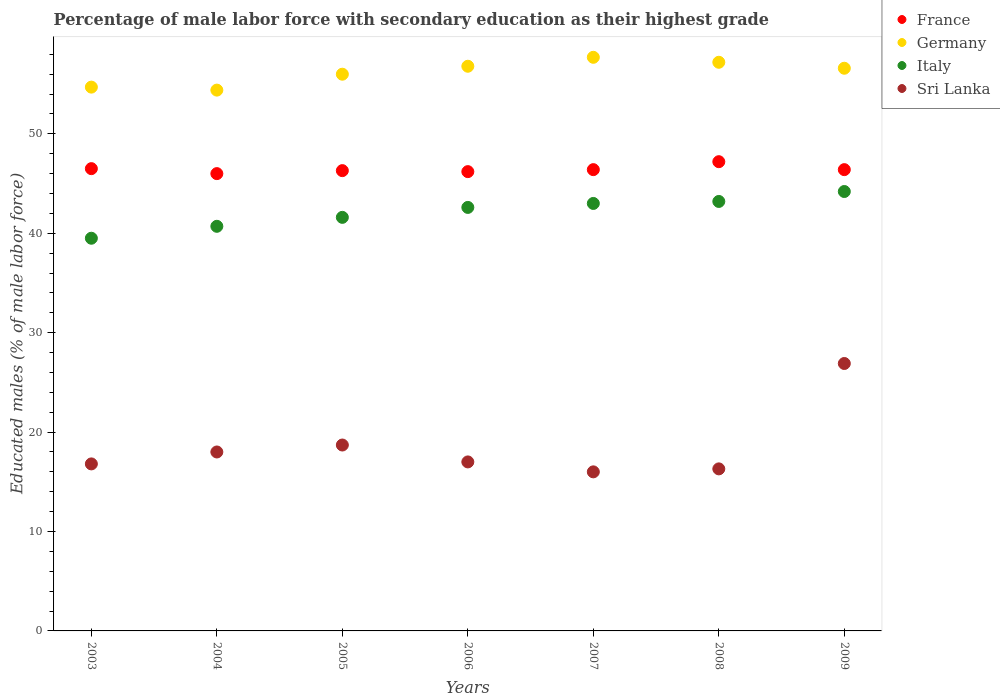How many different coloured dotlines are there?
Your answer should be very brief. 4. Across all years, what is the maximum percentage of male labor force with secondary education in Italy?
Provide a succinct answer. 44.2. Across all years, what is the minimum percentage of male labor force with secondary education in Italy?
Make the answer very short. 39.5. In which year was the percentage of male labor force with secondary education in France maximum?
Offer a very short reply. 2008. What is the total percentage of male labor force with secondary education in Sri Lanka in the graph?
Give a very brief answer. 129.7. What is the difference between the percentage of male labor force with secondary education in Germany in 2004 and that in 2005?
Give a very brief answer. -1.6. What is the difference between the percentage of male labor force with secondary education in Italy in 2005 and the percentage of male labor force with secondary education in Sri Lanka in 2009?
Make the answer very short. 14.7. What is the average percentage of male labor force with secondary education in Italy per year?
Provide a succinct answer. 42.11. In the year 2006, what is the difference between the percentage of male labor force with secondary education in France and percentage of male labor force with secondary education in Italy?
Give a very brief answer. 3.6. What is the ratio of the percentage of male labor force with secondary education in Sri Lanka in 2005 to that in 2008?
Provide a succinct answer. 1.15. What is the difference between the highest and the second highest percentage of male labor force with secondary education in Sri Lanka?
Provide a short and direct response. 8.2. What is the difference between the highest and the lowest percentage of male labor force with secondary education in Italy?
Offer a very short reply. 4.7. In how many years, is the percentage of male labor force with secondary education in Italy greater than the average percentage of male labor force with secondary education in Italy taken over all years?
Offer a terse response. 4. Is it the case that in every year, the sum of the percentage of male labor force with secondary education in Italy and percentage of male labor force with secondary education in Sri Lanka  is greater than the sum of percentage of male labor force with secondary education in France and percentage of male labor force with secondary education in Germany?
Provide a succinct answer. No. Does the percentage of male labor force with secondary education in Sri Lanka monotonically increase over the years?
Offer a very short reply. No. Is the percentage of male labor force with secondary education in Italy strictly greater than the percentage of male labor force with secondary education in France over the years?
Offer a very short reply. No. What is the difference between two consecutive major ticks on the Y-axis?
Provide a succinct answer. 10. Are the values on the major ticks of Y-axis written in scientific E-notation?
Offer a terse response. No. Where does the legend appear in the graph?
Your response must be concise. Top right. How many legend labels are there?
Offer a terse response. 4. What is the title of the graph?
Provide a short and direct response. Percentage of male labor force with secondary education as their highest grade. Does "Moldova" appear as one of the legend labels in the graph?
Your response must be concise. No. What is the label or title of the X-axis?
Keep it short and to the point. Years. What is the label or title of the Y-axis?
Make the answer very short. Educated males (% of male labor force). What is the Educated males (% of male labor force) in France in 2003?
Offer a very short reply. 46.5. What is the Educated males (% of male labor force) of Germany in 2003?
Provide a short and direct response. 54.7. What is the Educated males (% of male labor force) of Italy in 2003?
Offer a terse response. 39.5. What is the Educated males (% of male labor force) in Sri Lanka in 2003?
Your answer should be very brief. 16.8. What is the Educated males (% of male labor force) in France in 2004?
Offer a very short reply. 46. What is the Educated males (% of male labor force) in Germany in 2004?
Your answer should be compact. 54.4. What is the Educated males (% of male labor force) of Italy in 2004?
Make the answer very short. 40.7. What is the Educated males (% of male labor force) in France in 2005?
Your answer should be compact. 46.3. What is the Educated males (% of male labor force) in Italy in 2005?
Make the answer very short. 41.6. What is the Educated males (% of male labor force) of Sri Lanka in 2005?
Give a very brief answer. 18.7. What is the Educated males (% of male labor force) of France in 2006?
Keep it short and to the point. 46.2. What is the Educated males (% of male labor force) in Germany in 2006?
Your answer should be compact. 56.8. What is the Educated males (% of male labor force) of Italy in 2006?
Provide a short and direct response. 42.6. What is the Educated males (% of male labor force) in France in 2007?
Offer a very short reply. 46.4. What is the Educated males (% of male labor force) in Germany in 2007?
Offer a very short reply. 57.7. What is the Educated males (% of male labor force) in Italy in 2007?
Give a very brief answer. 43. What is the Educated males (% of male labor force) in France in 2008?
Your answer should be compact. 47.2. What is the Educated males (% of male labor force) of Germany in 2008?
Provide a short and direct response. 57.2. What is the Educated males (% of male labor force) in Italy in 2008?
Ensure brevity in your answer.  43.2. What is the Educated males (% of male labor force) in Sri Lanka in 2008?
Give a very brief answer. 16.3. What is the Educated males (% of male labor force) in France in 2009?
Make the answer very short. 46.4. What is the Educated males (% of male labor force) of Germany in 2009?
Keep it short and to the point. 56.6. What is the Educated males (% of male labor force) in Italy in 2009?
Offer a very short reply. 44.2. What is the Educated males (% of male labor force) of Sri Lanka in 2009?
Make the answer very short. 26.9. Across all years, what is the maximum Educated males (% of male labor force) in France?
Your answer should be compact. 47.2. Across all years, what is the maximum Educated males (% of male labor force) of Germany?
Your response must be concise. 57.7. Across all years, what is the maximum Educated males (% of male labor force) in Italy?
Keep it short and to the point. 44.2. Across all years, what is the maximum Educated males (% of male labor force) of Sri Lanka?
Offer a very short reply. 26.9. Across all years, what is the minimum Educated males (% of male labor force) in France?
Give a very brief answer. 46. Across all years, what is the minimum Educated males (% of male labor force) of Germany?
Your answer should be very brief. 54.4. Across all years, what is the minimum Educated males (% of male labor force) in Italy?
Offer a terse response. 39.5. What is the total Educated males (% of male labor force) in France in the graph?
Make the answer very short. 325. What is the total Educated males (% of male labor force) of Germany in the graph?
Provide a succinct answer. 393.4. What is the total Educated males (% of male labor force) in Italy in the graph?
Provide a succinct answer. 294.8. What is the total Educated males (% of male labor force) in Sri Lanka in the graph?
Keep it short and to the point. 129.7. What is the difference between the Educated males (% of male labor force) in France in 2003 and that in 2004?
Your response must be concise. 0.5. What is the difference between the Educated males (% of male labor force) in Germany in 2003 and that in 2004?
Your response must be concise. 0.3. What is the difference between the Educated males (% of male labor force) in Sri Lanka in 2003 and that in 2004?
Keep it short and to the point. -1.2. What is the difference between the Educated males (% of male labor force) in Germany in 2003 and that in 2005?
Give a very brief answer. -1.3. What is the difference between the Educated males (% of male labor force) of Italy in 2003 and that in 2005?
Your answer should be very brief. -2.1. What is the difference between the Educated males (% of male labor force) in Sri Lanka in 2003 and that in 2005?
Provide a short and direct response. -1.9. What is the difference between the Educated males (% of male labor force) in France in 2003 and that in 2006?
Give a very brief answer. 0.3. What is the difference between the Educated males (% of male labor force) of Germany in 2003 and that in 2006?
Your response must be concise. -2.1. What is the difference between the Educated males (% of male labor force) of Italy in 2003 and that in 2006?
Ensure brevity in your answer.  -3.1. What is the difference between the Educated males (% of male labor force) of France in 2003 and that in 2007?
Your answer should be compact. 0.1. What is the difference between the Educated males (% of male labor force) of Sri Lanka in 2003 and that in 2007?
Your response must be concise. 0.8. What is the difference between the Educated males (% of male labor force) in France in 2003 and that in 2008?
Keep it short and to the point. -0.7. What is the difference between the Educated males (% of male labor force) of Germany in 2003 and that in 2008?
Give a very brief answer. -2.5. What is the difference between the Educated males (% of male labor force) of Italy in 2003 and that in 2008?
Provide a succinct answer. -3.7. What is the difference between the Educated males (% of male labor force) in France in 2003 and that in 2009?
Offer a terse response. 0.1. What is the difference between the Educated males (% of male labor force) of Italy in 2003 and that in 2009?
Make the answer very short. -4.7. What is the difference between the Educated males (% of male labor force) of Sri Lanka in 2003 and that in 2009?
Provide a succinct answer. -10.1. What is the difference between the Educated males (% of male labor force) of France in 2004 and that in 2005?
Offer a very short reply. -0.3. What is the difference between the Educated males (% of male labor force) of Germany in 2004 and that in 2005?
Offer a very short reply. -1.6. What is the difference between the Educated males (% of male labor force) of Italy in 2004 and that in 2005?
Your answer should be compact. -0.9. What is the difference between the Educated males (% of male labor force) of Sri Lanka in 2004 and that in 2005?
Keep it short and to the point. -0.7. What is the difference between the Educated males (% of male labor force) in France in 2004 and that in 2006?
Offer a terse response. -0.2. What is the difference between the Educated males (% of male labor force) in Germany in 2004 and that in 2006?
Your answer should be compact. -2.4. What is the difference between the Educated males (% of male labor force) of Sri Lanka in 2004 and that in 2006?
Ensure brevity in your answer.  1. What is the difference between the Educated males (% of male labor force) of France in 2004 and that in 2007?
Give a very brief answer. -0.4. What is the difference between the Educated males (% of male labor force) in France in 2004 and that in 2008?
Keep it short and to the point. -1.2. What is the difference between the Educated males (% of male labor force) in Germany in 2004 and that in 2008?
Offer a terse response. -2.8. What is the difference between the Educated males (% of male labor force) in Italy in 2004 and that in 2008?
Make the answer very short. -2.5. What is the difference between the Educated males (% of male labor force) in France in 2005 and that in 2006?
Give a very brief answer. 0.1. What is the difference between the Educated males (% of male labor force) in Germany in 2005 and that in 2006?
Provide a succinct answer. -0.8. What is the difference between the Educated males (% of male labor force) in Italy in 2005 and that in 2006?
Provide a short and direct response. -1. What is the difference between the Educated males (% of male labor force) of France in 2005 and that in 2007?
Your response must be concise. -0.1. What is the difference between the Educated males (% of male labor force) of France in 2005 and that in 2008?
Offer a very short reply. -0.9. What is the difference between the Educated males (% of male labor force) in Italy in 2005 and that in 2008?
Your response must be concise. -1.6. What is the difference between the Educated males (% of male labor force) of Sri Lanka in 2005 and that in 2008?
Offer a very short reply. 2.4. What is the difference between the Educated males (% of male labor force) of France in 2005 and that in 2009?
Keep it short and to the point. -0.1. What is the difference between the Educated males (% of male labor force) in Germany in 2005 and that in 2009?
Keep it short and to the point. -0.6. What is the difference between the Educated males (% of male labor force) of Italy in 2005 and that in 2009?
Give a very brief answer. -2.6. What is the difference between the Educated males (% of male labor force) in France in 2006 and that in 2007?
Make the answer very short. -0.2. What is the difference between the Educated males (% of male labor force) in Germany in 2006 and that in 2007?
Make the answer very short. -0.9. What is the difference between the Educated males (% of male labor force) in Sri Lanka in 2006 and that in 2007?
Ensure brevity in your answer.  1. What is the difference between the Educated males (% of male labor force) in Germany in 2006 and that in 2008?
Give a very brief answer. -0.4. What is the difference between the Educated males (% of male labor force) in Italy in 2006 and that in 2008?
Offer a terse response. -0.6. What is the difference between the Educated males (% of male labor force) in France in 2006 and that in 2009?
Your answer should be very brief. -0.2. What is the difference between the Educated males (% of male labor force) of Sri Lanka in 2006 and that in 2009?
Ensure brevity in your answer.  -9.9. What is the difference between the Educated males (% of male labor force) of Italy in 2007 and that in 2008?
Ensure brevity in your answer.  -0.2. What is the difference between the Educated males (% of male labor force) in France in 2007 and that in 2009?
Your response must be concise. 0. What is the difference between the Educated males (% of male labor force) in Germany in 2007 and that in 2009?
Give a very brief answer. 1.1. What is the difference between the Educated males (% of male labor force) in Sri Lanka in 2007 and that in 2009?
Offer a terse response. -10.9. What is the difference between the Educated males (% of male labor force) in France in 2008 and that in 2009?
Offer a terse response. 0.8. What is the difference between the Educated males (% of male labor force) in Germany in 2008 and that in 2009?
Give a very brief answer. 0.6. What is the difference between the Educated males (% of male labor force) in Sri Lanka in 2008 and that in 2009?
Your response must be concise. -10.6. What is the difference between the Educated males (% of male labor force) in France in 2003 and the Educated males (% of male labor force) in Germany in 2004?
Your answer should be compact. -7.9. What is the difference between the Educated males (% of male labor force) of Germany in 2003 and the Educated males (% of male labor force) of Italy in 2004?
Your answer should be compact. 14. What is the difference between the Educated males (% of male labor force) in Germany in 2003 and the Educated males (% of male labor force) in Sri Lanka in 2004?
Offer a terse response. 36.7. What is the difference between the Educated males (% of male labor force) of Italy in 2003 and the Educated males (% of male labor force) of Sri Lanka in 2004?
Your answer should be very brief. 21.5. What is the difference between the Educated males (% of male labor force) of France in 2003 and the Educated males (% of male labor force) of Germany in 2005?
Provide a short and direct response. -9.5. What is the difference between the Educated males (% of male labor force) in France in 2003 and the Educated males (% of male labor force) in Italy in 2005?
Your response must be concise. 4.9. What is the difference between the Educated males (% of male labor force) of France in 2003 and the Educated males (% of male labor force) of Sri Lanka in 2005?
Ensure brevity in your answer.  27.8. What is the difference between the Educated males (% of male labor force) in Germany in 2003 and the Educated males (% of male labor force) in Italy in 2005?
Give a very brief answer. 13.1. What is the difference between the Educated males (% of male labor force) in Germany in 2003 and the Educated males (% of male labor force) in Sri Lanka in 2005?
Give a very brief answer. 36. What is the difference between the Educated males (% of male labor force) in Italy in 2003 and the Educated males (% of male labor force) in Sri Lanka in 2005?
Give a very brief answer. 20.8. What is the difference between the Educated males (% of male labor force) in France in 2003 and the Educated males (% of male labor force) in Italy in 2006?
Offer a very short reply. 3.9. What is the difference between the Educated males (% of male labor force) in France in 2003 and the Educated males (% of male labor force) in Sri Lanka in 2006?
Make the answer very short. 29.5. What is the difference between the Educated males (% of male labor force) in Germany in 2003 and the Educated males (% of male labor force) in Italy in 2006?
Make the answer very short. 12.1. What is the difference between the Educated males (% of male labor force) of Germany in 2003 and the Educated males (% of male labor force) of Sri Lanka in 2006?
Provide a short and direct response. 37.7. What is the difference between the Educated males (% of male labor force) of Italy in 2003 and the Educated males (% of male labor force) of Sri Lanka in 2006?
Make the answer very short. 22.5. What is the difference between the Educated males (% of male labor force) in France in 2003 and the Educated males (% of male labor force) in Italy in 2007?
Provide a short and direct response. 3.5. What is the difference between the Educated males (% of male labor force) in France in 2003 and the Educated males (% of male labor force) in Sri Lanka in 2007?
Your answer should be compact. 30.5. What is the difference between the Educated males (% of male labor force) in Germany in 2003 and the Educated males (% of male labor force) in Italy in 2007?
Make the answer very short. 11.7. What is the difference between the Educated males (% of male labor force) of Germany in 2003 and the Educated males (% of male labor force) of Sri Lanka in 2007?
Offer a very short reply. 38.7. What is the difference between the Educated males (% of male labor force) in France in 2003 and the Educated males (% of male labor force) in Germany in 2008?
Offer a very short reply. -10.7. What is the difference between the Educated males (% of male labor force) in France in 2003 and the Educated males (% of male labor force) in Sri Lanka in 2008?
Offer a very short reply. 30.2. What is the difference between the Educated males (% of male labor force) of Germany in 2003 and the Educated males (% of male labor force) of Italy in 2008?
Ensure brevity in your answer.  11.5. What is the difference between the Educated males (% of male labor force) of Germany in 2003 and the Educated males (% of male labor force) of Sri Lanka in 2008?
Provide a short and direct response. 38.4. What is the difference between the Educated males (% of male labor force) in Italy in 2003 and the Educated males (% of male labor force) in Sri Lanka in 2008?
Your answer should be compact. 23.2. What is the difference between the Educated males (% of male labor force) of France in 2003 and the Educated males (% of male labor force) of Germany in 2009?
Ensure brevity in your answer.  -10.1. What is the difference between the Educated males (% of male labor force) of France in 2003 and the Educated males (% of male labor force) of Italy in 2009?
Provide a short and direct response. 2.3. What is the difference between the Educated males (% of male labor force) of France in 2003 and the Educated males (% of male labor force) of Sri Lanka in 2009?
Offer a terse response. 19.6. What is the difference between the Educated males (% of male labor force) of Germany in 2003 and the Educated males (% of male labor force) of Italy in 2009?
Offer a terse response. 10.5. What is the difference between the Educated males (% of male labor force) of Germany in 2003 and the Educated males (% of male labor force) of Sri Lanka in 2009?
Your answer should be very brief. 27.8. What is the difference between the Educated males (% of male labor force) of Italy in 2003 and the Educated males (% of male labor force) of Sri Lanka in 2009?
Provide a succinct answer. 12.6. What is the difference between the Educated males (% of male labor force) in France in 2004 and the Educated males (% of male labor force) in Italy in 2005?
Your answer should be very brief. 4.4. What is the difference between the Educated males (% of male labor force) in France in 2004 and the Educated males (% of male labor force) in Sri Lanka in 2005?
Your answer should be compact. 27.3. What is the difference between the Educated males (% of male labor force) of Germany in 2004 and the Educated males (% of male labor force) of Sri Lanka in 2005?
Your answer should be very brief. 35.7. What is the difference between the Educated males (% of male labor force) of France in 2004 and the Educated males (% of male labor force) of Germany in 2006?
Provide a short and direct response. -10.8. What is the difference between the Educated males (% of male labor force) in Germany in 2004 and the Educated males (% of male labor force) in Sri Lanka in 2006?
Make the answer very short. 37.4. What is the difference between the Educated males (% of male labor force) of Italy in 2004 and the Educated males (% of male labor force) of Sri Lanka in 2006?
Offer a very short reply. 23.7. What is the difference between the Educated males (% of male labor force) of France in 2004 and the Educated males (% of male labor force) of Italy in 2007?
Ensure brevity in your answer.  3. What is the difference between the Educated males (% of male labor force) of France in 2004 and the Educated males (% of male labor force) of Sri Lanka in 2007?
Give a very brief answer. 30. What is the difference between the Educated males (% of male labor force) of Germany in 2004 and the Educated males (% of male labor force) of Italy in 2007?
Offer a terse response. 11.4. What is the difference between the Educated males (% of male labor force) in Germany in 2004 and the Educated males (% of male labor force) in Sri Lanka in 2007?
Ensure brevity in your answer.  38.4. What is the difference between the Educated males (% of male labor force) of Italy in 2004 and the Educated males (% of male labor force) of Sri Lanka in 2007?
Keep it short and to the point. 24.7. What is the difference between the Educated males (% of male labor force) of France in 2004 and the Educated males (% of male labor force) of Germany in 2008?
Make the answer very short. -11.2. What is the difference between the Educated males (% of male labor force) in France in 2004 and the Educated males (% of male labor force) in Italy in 2008?
Offer a very short reply. 2.8. What is the difference between the Educated males (% of male labor force) of France in 2004 and the Educated males (% of male labor force) of Sri Lanka in 2008?
Keep it short and to the point. 29.7. What is the difference between the Educated males (% of male labor force) of Germany in 2004 and the Educated males (% of male labor force) of Italy in 2008?
Make the answer very short. 11.2. What is the difference between the Educated males (% of male labor force) in Germany in 2004 and the Educated males (% of male labor force) in Sri Lanka in 2008?
Ensure brevity in your answer.  38.1. What is the difference between the Educated males (% of male labor force) in Italy in 2004 and the Educated males (% of male labor force) in Sri Lanka in 2008?
Ensure brevity in your answer.  24.4. What is the difference between the Educated males (% of male labor force) in France in 2004 and the Educated males (% of male labor force) in Italy in 2009?
Ensure brevity in your answer.  1.8. What is the difference between the Educated males (% of male labor force) in France in 2004 and the Educated males (% of male labor force) in Sri Lanka in 2009?
Provide a short and direct response. 19.1. What is the difference between the Educated males (% of male labor force) of Germany in 2004 and the Educated males (% of male labor force) of Italy in 2009?
Provide a succinct answer. 10.2. What is the difference between the Educated males (% of male labor force) of Germany in 2004 and the Educated males (% of male labor force) of Sri Lanka in 2009?
Give a very brief answer. 27.5. What is the difference between the Educated males (% of male labor force) in France in 2005 and the Educated males (% of male labor force) in Italy in 2006?
Offer a very short reply. 3.7. What is the difference between the Educated males (% of male labor force) in France in 2005 and the Educated males (% of male labor force) in Sri Lanka in 2006?
Make the answer very short. 29.3. What is the difference between the Educated males (% of male labor force) in Italy in 2005 and the Educated males (% of male labor force) in Sri Lanka in 2006?
Offer a terse response. 24.6. What is the difference between the Educated males (% of male labor force) of France in 2005 and the Educated males (% of male labor force) of Germany in 2007?
Provide a succinct answer. -11.4. What is the difference between the Educated males (% of male labor force) of France in 2005 and the Educated males (% of male labor force) of Italy in 2007?
Keep it short and to the point. 3.3. What is the difference between the Educated males (% of male labor force) in France in 2005 and the Educated males (% of male labor force) in Sri Lanka in 2007?
Offer a very short reply. 30.3. What is the difference between the Educated males (% of male labor force) in Germany in 2005 and the Educated males (% of male labor force) in Italy in 2007?
Your answer should be compact. 13. What is the difference between the Educated males (% of male labor force) of Germany in 2005 and the Educated males (% of male labor force) of Sri Lanka in 2007?
Provide a short and direct response. 40. What is the difference between the Educated males (% of male labor force) in Italy in 2005 and the Educated males (% of male labor force) in Sri Lanka in 2007?
Your answer should be very brief. 25.6. What is the difference between the Educated males (% of male labor force) of France in 2005 and the Educated males (% of male labor force) of Germany in 2008?
Your response must be concise. -10.9. What is the difference between the Educated males (% of male labor force) in France in 2005 and the Educated males (% of male labor force) in Sri Lanka in 2008?
Make the answer very short. 30. What is the difference between the Educated males (% of male labor force) of Germany in 2005 and the Educated males (% of male labor force) of Italy in 2008?
Your answer should be very brief. 12.8. What is the difference between the Educated males (% of male labor force) in Germany in 2005 and the Educated males (% of male labor force) in Sri Lanka in 2008?
Offer a very short reply. 39.7. What is the difference between the Educated males (% of male labor force) of Italy in 2005 and the Educated males (% of male labor force) of Sri Lanka in 2008?
Offer a very short reply. 25.3. What is the difference between the Educated males (% of male labor force) in France in 2005 and the Educated males (% of male labor force) in Germany in 2009?
Keep it short and to the point. -10.3. What is the difference between the Educated males (% of male labor force) in France in 2005 and the Educated males (% of male labor force) in Italy in 2009?
Give a very brief answer. 2.1. What is the difference between the Educated males (% of male labor force) in Germany in 2005 and the Educated males (% of male labor force) in Sri Lanka in 2009?
Your response must be concise. 29.1. What is the difference between the Educated males (% of male labor force) in Italy in 2005 and the Educated males (% of male labor force) in Sri Lanka in 2009?
Offer a terse response. 14.7. What is the difference between the Educated males (% of male labor force) of France in 2006 and the Educated males (% of male labor force) of Germany in 2007?
Give a very brief answer. -11.5. What is the difference between the Educated males (% of male labor force) of France in 2006 and the Educated males (% of male labor force) of Sri Lanka in 2007?
Provide a succinct answer. 30.2. What is the difference between the Educated males (% of male labor force) in Germany in 2006 and the Educated males (% of male labor force) in Sri Lanka in 2007?
Give a very brief answer. 40.8. What is the difference between the Educated males (% of male labor force) in Italy in 2006 and the Educated males (% of male labor force) in Sri Lanka in 2007?
Make the answer very short. 26.6. What is the difference between the Educated males (% of male labor force) of France in 2006 and the Educated males (% of male labor force) of Germany in 2008?
Offer a terse response. -11. What is the difference between the Educated males (% of male labor force) in France in 2006 and the Educated males (% of male labor force) in Italy in 2008?
Give a very brief answer. 3. What is the difference between the Educated males (% of male labor force) in France in 2006 and the Educated males (% of male labor force) in Sri Lanka in 2008?
Your response must be concise. 29.9. What is the difference between the Educated males (% of male labor force) in Germany in 2006 and the Educated males (% of male labor force) in Sri Lanka in 2008?
Your answer should be very brief. 40.5. What is the difference between the Educated males (% of male labor force) in Italy in 2006 and the Educated males (% of male labor force) in Sri Lanka in 2008?
Provide a succinct answer. 26.3. What is the difference between the Educated males (% of male labor force) of France in 2006 and the Educated males (% of male labor force) of Italy in 2009?
Keep it short and to the point. 2. What is the difference between the Educated males (% of male labor force) of France in 2006 and the Educated males (% of male labor force) of Sri Lanka in 2009?
Make the answer very short. 19.3. What is the difference between the Educated males (% of male labor force) in Germany in 2006 and the Educated males (% of male labor force) in Sri Lanka in 2009?
Provide a short and direct response. 29.9. What is the difference between the Educated males (% of male labor force) in France in 2007 and the Educated males (% of male labor force) in Germany in 2008?
Provide a succinct answer. -10.8. What is the difference between the Educated males (% of male labor force) of France in 2007 and the Educated males (% of male labor force) of Sri Lanka in 2008?
Your answer should be very brief. 30.1. What is the difference between the Educated males (% of male labor force) of Germany in 2007 and the Educated males (% of male labor force) of Italy in 2008?
Give a very brief answer. 14.5. What is the difference between the Educated males (% of male labor force) in Germany in 2007 and the Educated males (% of male labor force) in Sri Lanka in 2008?
Offer a very short reply. 41.4. What is the difference between the Educated males (% of male labor force) in Italy in 2007 and the Educated males (% of male labor force) in Sri Lanka in 2008?
Give a very brief answer. 26.7. What is the difference between the Educated males (% of male labor force) in France in 2007 and the Educated males (% of male labor force) in Germany in 2009?
Keep it short and to the point. -10.2. What is the difference between the Educated males (% of male labor force) in France in 2007 and the Educated males (% of male labor force) in Sri Lanka in 2009?
Offer a terse response. 19.5. What is the difference between the Educated males (% of male labor force) in Germany in 2007 and the Educated males (% of male labor force) in Italy in 2009?
Provide a short and direct response. 13.5. What is the difference between the Educated males (% of male labor force) of Germany in 2007 and the Educated males (% of male labor force) of Sri Lanka in 2009?
Ensure brevity in your answer.  30.8. What is the difference between the Educated males (% of male labor force) of Italy in 2007 and the Educated males (% of male labor force) of Sri Lanka in 2009?
Provide a succinct answer. 16.1. What is the difference between the Educated males (% of male labor force) of France in 2008 and the Educated males (% of male labor force) of Sri Lanka in 2009?
Make the answer very short. 20.3. What is the difference between the Educated males (% of male labor force) of Germany in 2008 and the Educated males (% of male labor force) of Sri Lanka in 2009?
Offer a very short reply. 30.3. What is the difference between the Educated males (% of male labor force) in Italy in 2008 and the Educated males (% of male labor force) in Sri Lanka in 2009?
Provide a short and direct response. 16.3. What is the average Educated males (% of male labor force) in France per year?
Provide a short and direct response. 46.43. What is the average Educated males (% of male labor force) of Germany per year?
Offer a very short reply. 56.2. What is the average Educated males (% of male labor force) of Italy per year?
Keep it short and to the point. 42.11. What is the average Educated males (% of male labor force) in Sri Lanka per year?
Ensure brevity in your answer.  18.53. In the year 2003, what is the difference between the Educated males (% of male labor force) in France and Educated males (% of male labor force) in Sri Lanka?
Your response must be concise. 29.7. In the year 2003, what is the difference between the Educated males (% of male labor force) of Germany and Educated males (% of male labor force) of Sri Lanka?
Ensure brevity in your answer.  37.9. In the year 2003, what is the difference between the Educated males (% of male labor force) of Italy and Educated males (% of male labor force) of Sri Lanka?
Provide a short and direct response. 22.7. In the year 2004, what is the difference between the Educated males (% of male labor force) of France and Educated males (% of male labor force) of Italy?
Make the answer very short. 5.3. In the year 2004, what is the difference between the Educated males (% of male labor force) in Germany and Educated males (% of male labor force) in Italy?
Ensure brevity in your answer.  13.7. In the year 2004, what is the difference between the Educated males (% of male labor force) of Germany and Educated males (% of male labor force) of Sri Lanka?
Keep it short and to the point. 36.4. In the year 2004, what is the difference between the Educated males (% of male labor force) of Italy and Educated males (% of male labor force) of Sri Lanka?
Offer a very short reply. 22.7. In the year 2005, what is the difference between the Educated males (% of male labor force) of France and Educated males (% of male labor force) of Sri Lanka?
Offer a very short reply. 27.6. In the year 2005, what is the difference between the Educated males (% of male labor force) in Germany and Educated males (% of male labor force) in Italy?
Provide a succinct answer. 14.4. In the year 2005, what is the difference between the Educated males (% of male labor force) of Germany and Educated males (% of male labor force) of Sri Lanka?
Provide a short and direct response. 37.3. In the year 2005, what is the difference between the Educated males (% of male labor force) in Italy and Educated males (% of male labor force) in Sri Lanka?
Make the answer very short. 22.9. In the year 2006, what is the difference between the Educated males (% of male labor force) in France and Educated males (% of male labor force) in Germany?
Ensure brevity in your answer.  -10.6. In the year 2006, what is the difference between the Educated males (% of male labor force) of France and Educated males (% of male labor force) of Sri Lanka?
Provide a succinct answer. 29.2. In the year 2006, what is the difference between the Educated males (% of male labor force) of Germany and Educated males (% of male labor force) of Italy?
Offer a very short reply. 14.2. In the year 2006, what is the difference between the Educated males (% of male labor force) of Germany and Educated males (% of male labor force) of Sri Lanka?
Give a very brief answer. 39.8. In the year 2006, what is the difference between the Educated males (% of male labor force) in Italy and Educated males (% of male labor force) in Sri Lanka?
Give a very brief answer. 25.6. In the year 2007, what is the difference between the Educated males (% of male labor force) of France and Educated males (% of male labor force) of Germany?
Ensure brevity in your answer.  -11.3. In the year 2007, what is the difference between the Educated males (% of male labor force) in France and Educated males (% of male labor force) in Sri Lanka?
Offer a terse response. 30.4. In the year 2007, what is the difference between the Educated males (% of male labor force) of Germany and Educated males (% of male labor force) of Italy?
Your response must be concise. 14.7. In the year 2007, what is the difference between the Educated males (% of male labor force) of Germany and Educated males (% of male labor force) of Sri Lanka?
Provide a succinct answer. 41.7. In the year 2007, what is the difference between the Educated males (% of male labor force) of Italy and Educated males (% of male labor force) of Sri Lanka?
Offer a terse response. 27. In the year 2008, what is the difference between the Educated males (% of male labor force) of France and Educated males (% of male labor force) of Italy?
Your answer should be compact. 4. In the year 2008, what is the difference between the Educated males (% of male labor force) of France and Educated males (% of male labor force) of Sri Lanka?
Provide a short and direct response. 30.9. In the year 2008, what is the difference between the Educated males (% of male labor force) in Germany and Educated males (% of male labor force) in Sri Lanka?
Your answer should be compact. 40.9. In the year 2008, what is the difference between the Educated males (% of male labor force) in Italy and Educated males (% of male labor force) in Sri Lanka?
Keep it short and to the point. 26.9. In the year 2009, what is the difference between the Educated males (% of male labor force) of France and Educated males (% of male labor force) of Germany?
Provide a succinct answer. -10.2. In the year 2009, what is the difference between the Educated males (% of male labor force) in France and Educated males (% of male labor force) in Sri Lanka?
Offer a very short reply. 19.5. In the year 2009, what is the difference between the Educated males (% of male labor force) of Germany and Educated males (% of male labor force) of Sri Lanka?
Give a very brief answer. 29.7. In the year 2009, what is the difference between the Educated males (% of male labor force) of Italy and Educated males (% of male labor force) of Sri Lanka?
Make the answer very short. 17.3. What is the ratio of the Educated males (% of male labor force) of France in 2003 to that in 2004?
Keep it short and to the point. 1.01. What is the ratio of the Educated males (% of male labor force) of Germany in 2003 to that in 2004?
Keep it short and to the point. 1.01. What is the ratio of the Educated males (% of male labor force) of Italy in 2003 to that in 2004?
Give a very brief answer. 0.97. What is the ratio of the Educated males (% of male labor force) of Sri Lanka in 2003 to that in 2004?
Give a very brief answer. 0.93. What is the ratio of the Educated males (% of male labor force) in France in 2003 to that in 2005?
Provide a succinct answer. 1. What is the ratio of the Educated males (% of male labor force) in Germany in 2003 to that in 2005?
Provide a succinct answer. 0.98. What is the ratio of the Educated males (% of male labor force) in Italy in 2003 to that in 2005?
Your response must be concise. 0.95. What is the ratio of the Educated males (% of male labor force) of Sri Lanka in 2003 to that in 2005?
Your answer should be compact. 0.9. What is the ratio of the Educated males (% of male labor force) of Italy in 2003 to that in 2006?
Give a very brief answer. 0.93. What is the ratio of the Educated males (% of male labor force) in France in 2003 to that in 2007?
Provide a succinct answer. 1. What is the ratio of the Educated males (% of male labor force) of Germany in 2003 to that in 2007?
Provide a short and direct response. 0.95. What is the ratio of the Educated males (% of male labor force) of Italy in 2003 to that in 2007?
Ensure brevity in your answer.  0.92. What is the ratio of the Educated males (% of male labor force) of Sri Lanka in 2003 to that in 2007?
Your answer should be compact. 1.05. What is the ratio of the Educated males (% of male labor force) in France in 2003 to that in 2008?
Give a very brief answer. 0.99. What is the ratio of the Educated males (% of male labor force) of Germany in 2003 to that in 2008?
Your response must be concise. 0.96. What is the ratio of the Educated males (% of male labor force) of Italy in 2003 to that in 2008?
Your response must be concise. 0.91. What is the ratio of the Educated males (% of male labor force) of Sri Lanka in 2003 to that in 2008?
Your answer should be compact. 1.03. What is the ratio of the Educated males (% of male labor force) in Germany in 2003 to that in 2009?
Your answer should be compact. 0.97. What is the ratio of the Educated males (% of male labor force) in Italy in 2003 to that in 2009?
Offer a terse response. 0.89. What is the ratio of the Educated males (% of male labor force) of Sri Lanka in 2003 to that in 2009?
Your answer should be compact. 0.62. What is the ratio of the Educated males (% of male labor force) of France in 2004 to that in 2005?
Ensure brevity in your answer.  0.99. What is the ratio of the Educated males (% of male labor force) of Germany in 2004 to that in 2005?
Provide a short and direct response. 0.97. What is the ratio of the Educated males (% of male labor force) in Italy in 2004 to that in 2005?
Your answer should be compact. 0.98. What is the ratio of the Educated males (% of male labor force) of Sri Lanka in 2004 to that in 2005?
Make the answer very short. 0.96. What is the ratio of the Educated males (% of male labor force) in Germany in 2004 to that in 2006?
Offer a very short reply. 0.96. What is the ratio of the Educated males (% of male labor force) of Italy in 2004 to that in 2006?
Keep it short and to the point. 0.96. What is the ratio of the Educated males (% of male labor force) in Sri Lanka in 2004 to that in 2006?
Ensure brevity in your answer.  1.06. What is the ratio of the Educated males (% of male labor force) of France in 2004 to that in 2007?
Provide a succinct answer. 0.99. What is the ratio of the Educated males (% of male labor force) in Germany in 2004 to that in 2007?
Make the answer very short. 0.94. What is the ratio of the Educated males (% of male labor force) in Italy in 2004 to that in 2007?
Make the answer very short. 0.95. What is the ratio of the Educated males (% of male labor force) in Sri Lanka in 2004 to that in 2007?
Provide a succinct answer. 1.12. What is the ratio of the Educated males (% of male labor force) of France in 2004 to that in 2008?
Make the answer very short. 0.97. What is the ratio of the Educated males (% of male labor force) of Germany in 2004 to that in 2008?
Your answer should be compact. 0.95. What is the ratio of the Educated males (% of male labor force) of Italy in 2004 to that in 2008?
Your answer should be compact. 0.94. What is the ratio of the Educated males (% of male labor force) in Sri Lanka in 2004 to that in 2008?
Give a very brief answer. 1.1. What is the ratio of the Educated males (% of male labor force) in Germany in 2004 to that in 2009?
Your answer should be compact. 0.96. What is the ratio of the Educated males (% of male labor force) in Italy in 2004 to that in 2009?
Make the answer very short. 0.92. What is the ratio of the Educated males (% of male labor force) of Sri Lanka in 2004 to that in 2009?
Ensure brevity in your answer.  0.67. What is the ratio of the Educated males (% of male labor force) in Germany in 2005 to that in 2006?
Offer a very short reply. 0.99. What is the ratio of the Educated males (% of male labor force) of Italy in 2005 to that in 2006?
Keep it short and to the point. 0.98. What is the ratio of the Educated males (% of male labor force) of Germany in 2005 to that in 2007?
Make the answer very short. 0.97. What is the ratio of the Educated males (% of male labor force) of Italy in 2005 to that in 2007?
Offer a very short reply. 0.97. What is the ratio of the Educated males (% of male labor force) in Sri Lanka in 2005 to that in 2007?
Ensure brevity in your answer.  1.17. What is the ratio of the Educated males (% of male labor force) of France in 2005 to that in 2008?
Offer a terse response. 0.98. What is the ratio of the Educated males (% of male labor force) of Italy in 2005 to that in 2008?
Offer a terse response. 0.96. What is the ratio of the Educated males (% of male labor force) of Sri Lanka in 2005 to that in 2008?
Give a very brief answer. 1.15. What is the ratio of the Educated males (% of male labor force) of Italy in 2005 to that in 2009?
Keep it short and to the point. 0.94. What is the ratio of the Educated males (% of male labor force) of Sri Lanka in 2005 to that in 2009?
Ensure brevity in your answer.  0.7. What is the ratio of the Educated males (% of male labor force) of France in 2006 to that in 2007?
Your answer should be very brief. 1. What is the ratio of the Educated males (% of male labor force) of Germany in 2006 to that in 2007?
Your answer should be very brief. 0.98. What is the ratio of the Educated males (% of male labor force) of Italy in 2006 to that in 2007?
Keep it short and to the point. 0.99. What is the ratio of the Educated males (% of male labor force) in France in 2006 to that in 2008?
Provide a short and direct response. 0.98. What is the ratio of the Educated males (% of male labor force) in Italy in 2006 to that in 2008?
Make the answer very short. 0.99. What is the ratio of the Educated males (% of male labor force) of Sri Lanka in 2006 to that in 2008?
Provide a succinct answer. 1.04. What is the ratio of the Educated males (% of male labor force) in France in 2006 to that in 2009?
Your answer should be compact. 1. What is the ratio of the Educated males (% of male labor force) in Italy in 2006 to that in 2009?
Make the answer very short. 0.96. What is the ratio of the Educated males (% of male labor force) in Sri Lanka in 2006 to that in 2009?
Offer a very short reply. 0.63. What is the ratio of the Educated males (% of male labor force) of France in 2007 to that in 2008?
Make the answer very short. 0.98. What is the ratio of the Educated males (% of male labor force) in Germany in 2007 to that in 2008?
Give a very brief answer. 1.01. What is the ratio of the Educated males (% of male labor force) of Italy in 2007 to that in 2008?
Make the answer very short. 1. What is the ratio of the Educated males (% of male labor force) in Sri Lanka in 2007 to that in 2008?
Your answer should be compact. 0.98. What is the ratio of the Educated males (% of male labor force) of France in 2007 to that in 2009?
Ensure brevity in your answer.  1. What is the ratio of the Educated males (% of male labor force) in Germany in 2007 to that in 2009?
Your response must be concise. 1.02. What is the ratio of the Educated males (% of male labor force) of Italy in 2007 to that in 2009?
Provide a short and direct response. 0.97. What is the ratio of the Educated males (% of male labor force) in Sri Lanka in 2007 to that in 2009?
Keep it short and to the point. 0.59. What is the ratio of the Educated males (% of male labor force) of France in 2008 to that in 2009?
Keep it short and to the point. 1.02. What is the ratio of the Educated males (% of male labor force) in Germany in 2008 to that in 2009?
Your answer should be very brief. 1.01. What is the ratio of the Educated males (% of male labor force) in Italy in 2008 to that in 2009?
Give a very brief answer. 0.98. What is the ratio of the Educated males (% of male labor force) of Sri Lanka in 2008 to that in 2009?
Provide a succinct answer. 0.61. What is the difference between the highest and the second highest Educated males (% of male labor force) in France?
Your answer should be compact. 0.7. What is the difference between the highest and the second highest Educated males (% of male labor force) of Italy?
Your answer should be compact. 1. What is the difference between the highest and the second highest Educated males (% of male labor force) in Sri Lanka?
Your response must be concise. 8.2. What is the difference between the highest and the lowest Educated males (% of male labor force) in Germany?
Give a very brief answer. 3.3. What is the difference between the highest and the lowest Educated males (% of male labor force) of Italy?
Give a very brief answer. 4.7. What is the difference between the highest and the lowest Educated males (% of male labor force) of Sri Lanka?
Keep it short and to the point. 10.9. 